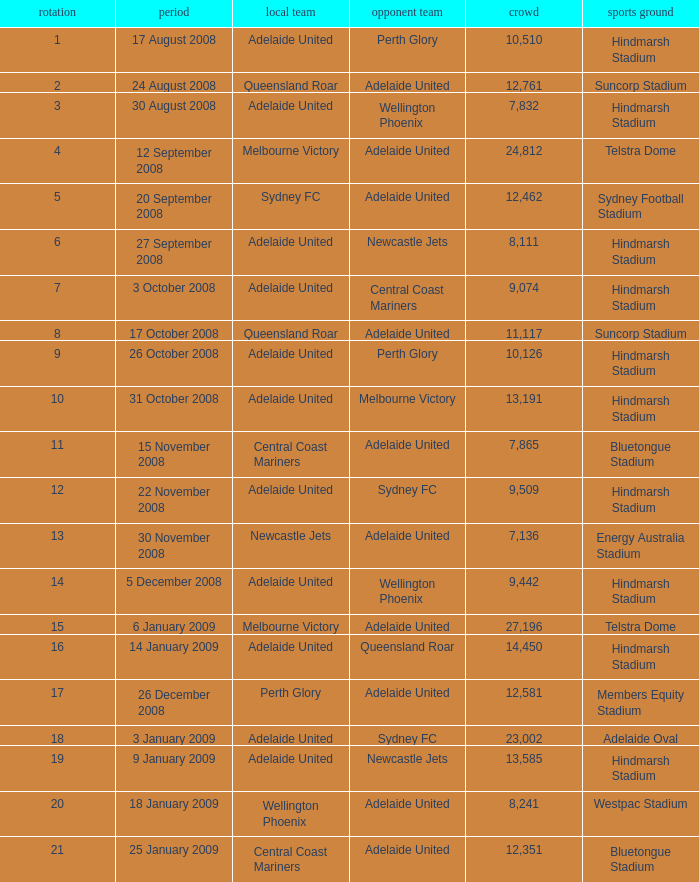Who was the away team when Queensland Roar was the home team in the round less than 3? Adelaide United. 